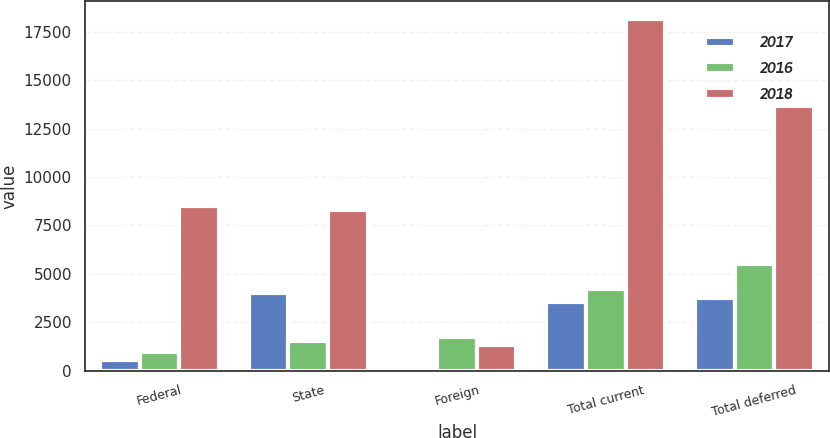Convert chart. <chart><loc_0><loc_0><loc_500><loc_500><stacked_bar_chart><ecel><fcel>Federal<fcel>State<fcel>Foreign<fcel>Total current<fcel>Total deferred<nl><fcel>2017<fcel>568<fcel>4003<fcel>84<fcel>3519<fcel>3761<nl><fcel>2016<fcel>949<fcel>1504<fcel>1737<fcel>4190<fcel>5523<nl><fcel>2018<fcel>8525<fcel>8307<fcel>1332<fcel>18164<fcel>13691<nl></chart> 